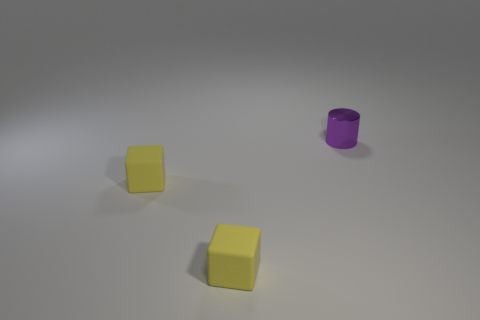Add 2 large purple rubber things. How many objects exist? 5 Subtract all cylinders. How many objects are left? 2 Add 3 yellow things. How many yellow things are left? 5 Add 1 purple matte spheres. How many purple matte spheres exist? 1 Subtract 0 red cylinders. How many objects are left? 3 Subtract all small metal things. Subtract all large cyan shiny cylinders. How many objects are left? 2 